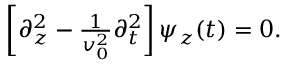Convert formula to latex. <formula><loc_0><loc_0><loc_500><loc_500>\begin{array} { r } { \left [ \partial _ { z } ^ { 2 } - \frac { 1 } { v _ { 0 } ^ { 2 } } \partial _ { t } ^ { 2 } \right ] \psi _ { z } ( t ) = 0 . } \end{array}</formula> 